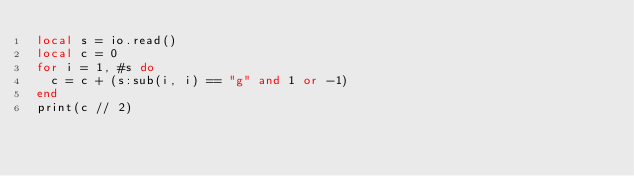Convert code to text. <code><loc_0><loc_0><loc_500><loc_500><_Lua_>local s = io.read()
local c = 0
for i = 1, #s do
  c = c + (s:sub(i, i) == "g" and 1 or -1)
end
print(c // 2)
</code> 